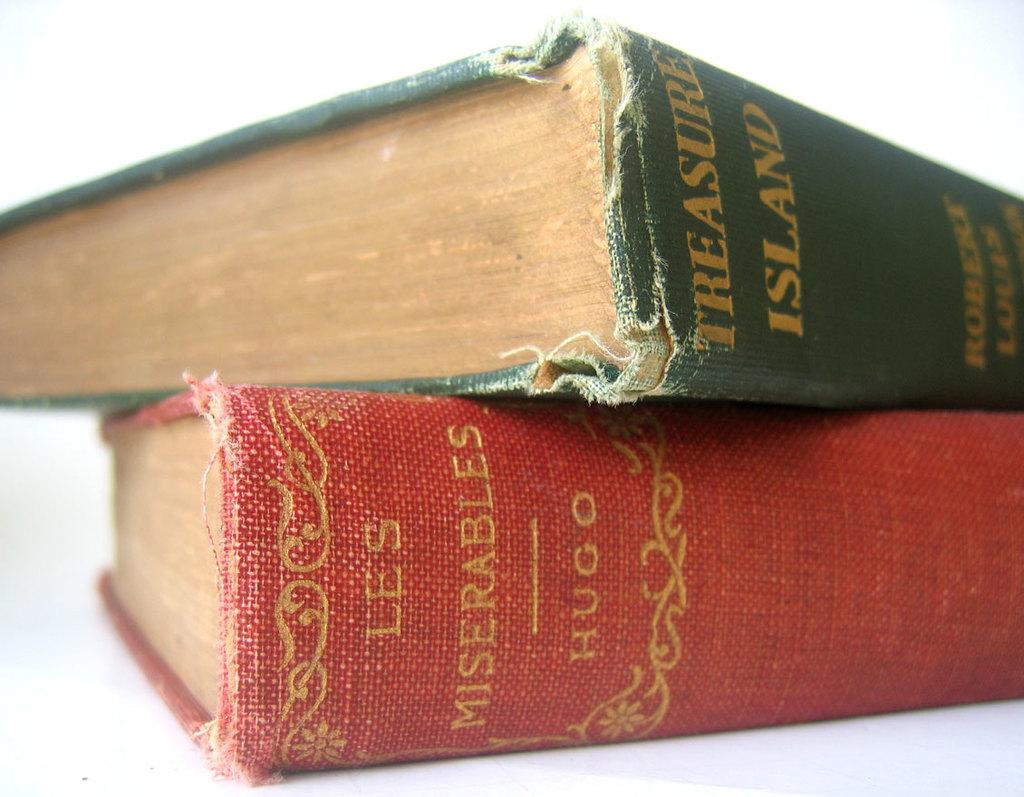What is the title of the red book?
Ensure brevity in your answer.  Les miserables. 